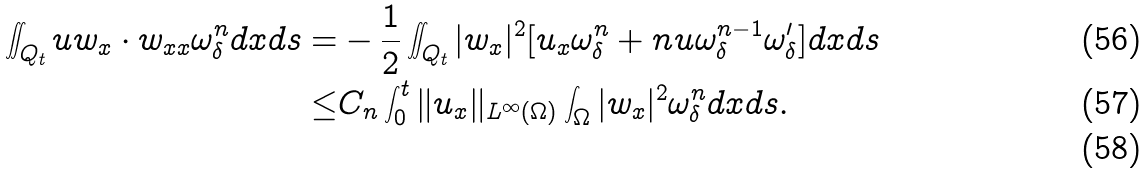<formula> <loc_0><loc_0><loc_500><loc_500>\iint _ { Q _ { t } } u w _ { x } \cdot w _ { x x } \omega _ { \delta } ^ { n } d x d s = & - \frac { 1 } { 2 } \iint _ { Q _ { t } } | w _ { x } | ^ { 2 } [ u _ { x } \omega _ { \delta } ^ { n } + n u \omega _ { \delta } ^ { n - 1 } \omega _ { \delta } ^ { \prime } ] d x d s \\ \leq & C _ { n } \int _ { 0 } ^ { t } \| u _ { x } \| _ { L ^ { \infty } ( \Omega ) } \int _ { \Omega } | w _ { x } | ^ { 2 } \omega _ { \delta } ^ { n } d x d s . \\</formula> 